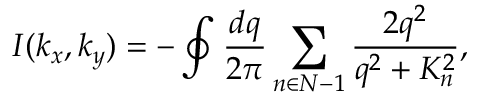<formula> <loc_0><loc_0><loc_500><loc_500>I ( k _ { x } , k _ { y } ) = - \oint \frac { d q } { 2 \pi } \sum _ { n \in N - 1 } \frac { 2 q ^ { 2 } } { q ^ { 2 } + K _ { n } ^ { 2 } } ,</formula> 